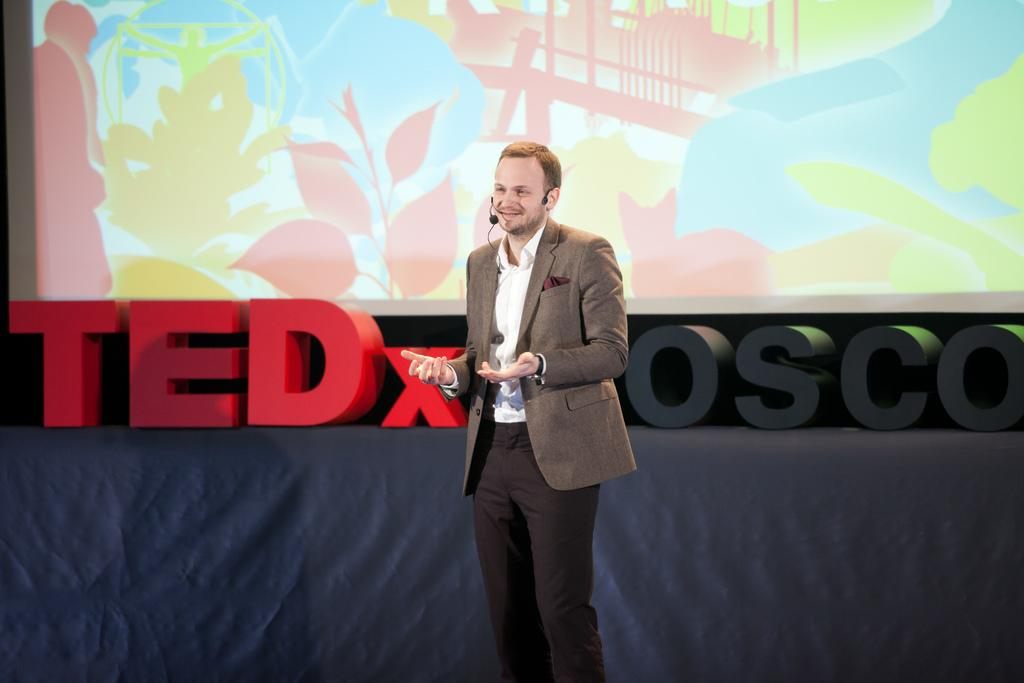What is the main subject of the image? There is a man in the image. What is the man doing in the image? The man is standing and smiling. What can be seen in the background of the image? There is a screen and a name board on an object in the background of the image. What type of food is the man cooking in the image? There is no indication in the image that the man is cooking any food, so it cannot be determined from the picture. 